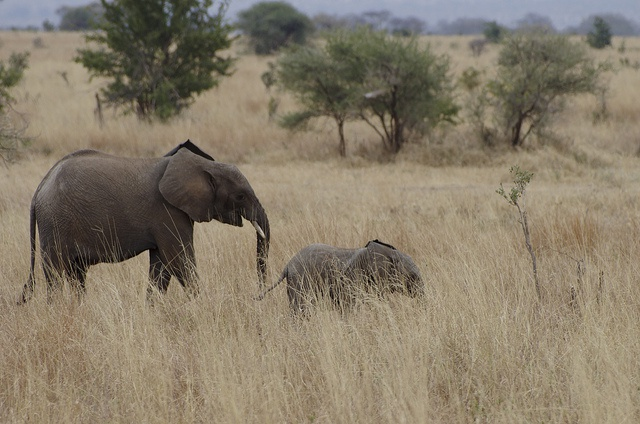Describe the objects in this image and their specific colors. I can see elephant in gray and black tones and elephant in gray and darkgray tones in this image. 